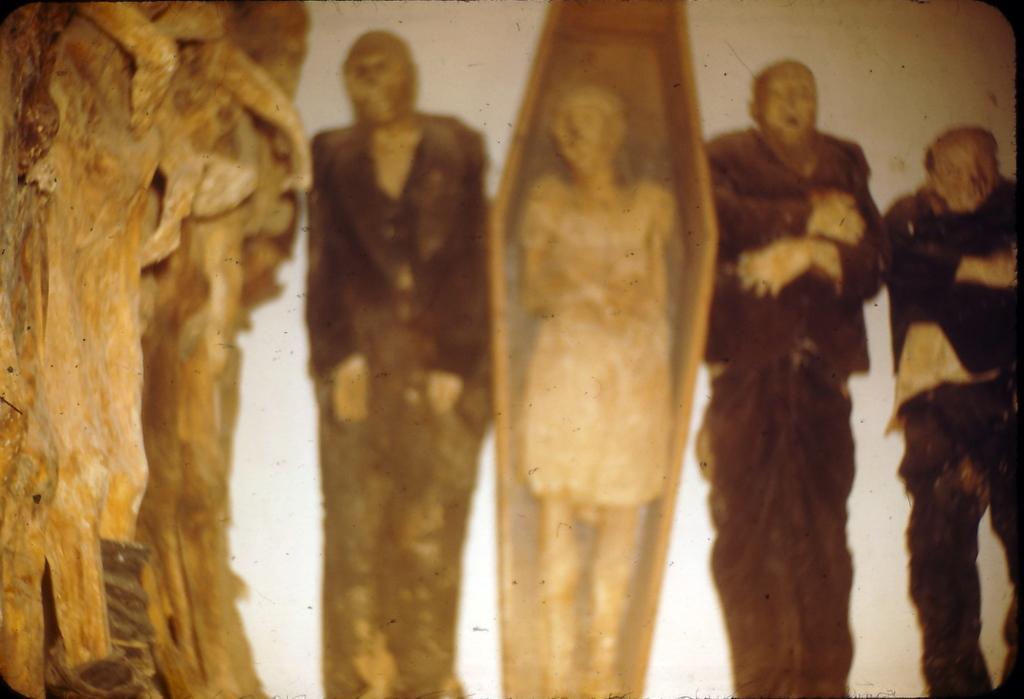Please provide a concise description of this image. In this image we can see a painting were three men are lying and one lady is lying in the box. Left side of the image some sculpture is there. 